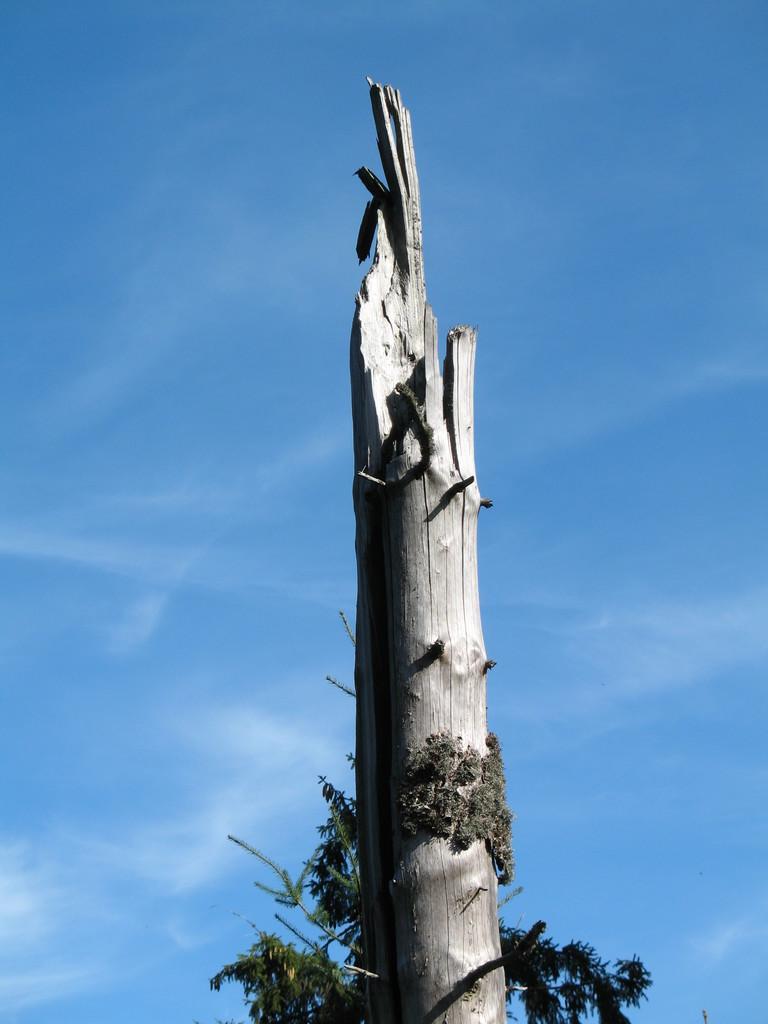Can you describe this image briefly? In this picture, there is a tree trunk. In the background, there is a sky with clouds. 